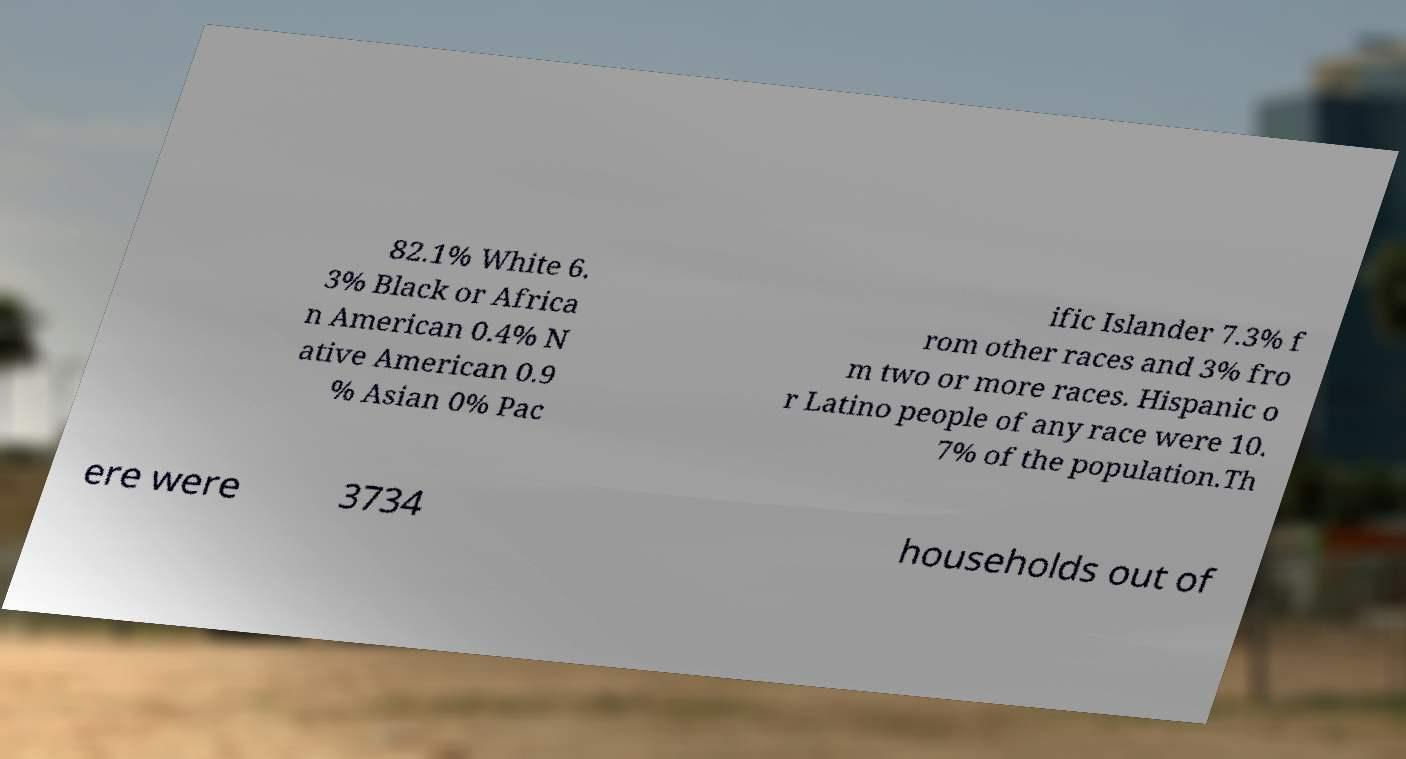Can you accurately transcribe the text from the provided image for me? 82.1% White 6. 3% Black or Africa n American 0.4% N ative American 0.9 % Asian 0% Pac ific Islander 7.3% f rom other races and 3% fro m two or more races. Hispanic o r Latino people of any race were 10. 7% of the population.Th ere were 3734 households out of 